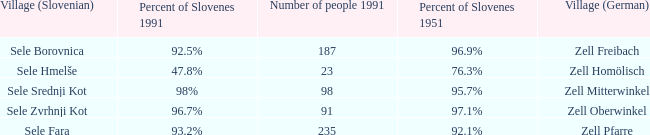Provide me with the name of all the village (German) that are part of the village (Slovenian) with sele borovnica. Zell Freibach. 